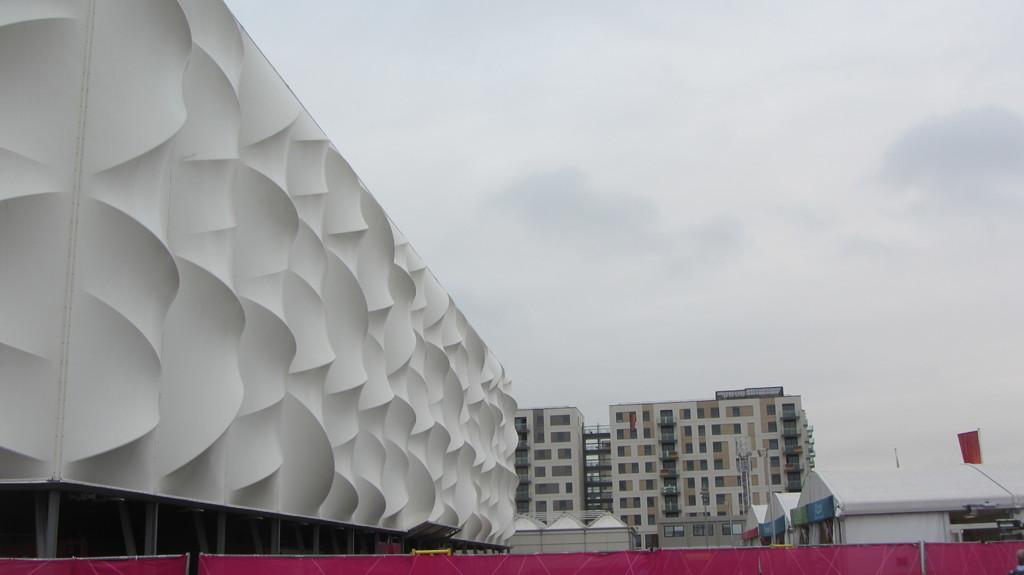How would you summarize this image in a sentence or two? In this image we can see a group of buildings and a flag. In the background, we can see the cloudy sky. 